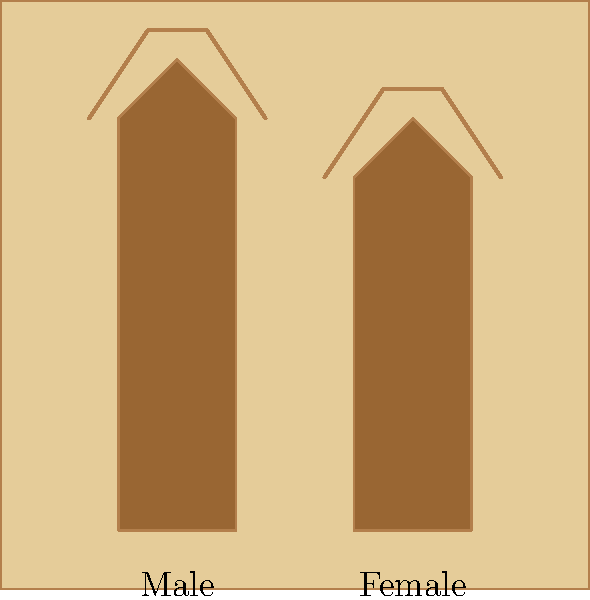Analyze the representation of gender in this simplified ancient Egyptian-style artwork. What key difference in the depiction of the male and female figures challenges traditional assumptions about gender roles in ancient Egyptian society? To answer this question, we need to analyze the image carefully and consider its implications for gender representation in ancient Egyptian art:

1. Overall composition: The image shows two stylized figures, one labeled male and one labeled female, in a typical ancient Egyptian artistic style.

2. Height comparison: Contrary to many ancient artistic traditions, the male and female figures are depicted at almost equal heights. The male figure is only slightly taller than the female figure.

3. Posture and stance: Both figures are shown in a similar, upright posture, suggesting equal status and importance.

4. Crowns: Both figures wear crowns, which in ancient Egyptian art often signify royalty, divinity, or high social status. The presence of crowns on both figures implies equal access to power and authority.

5. Clothing: The simplified representation doesn't show significant differences in clothing between the male and female figures, further emphasizing their equality.

6. Proportions: The body proportions of both figures are similar, without exaggerated sexual characteristics that might emphasize gender differences.

The key difference challenging traditional assumptions is the near-equal height and status representation of the male and female figures. This contrasts with many ancient artistic traditions where male figures are often depicted as significantly larger or in more dominant positions than female figures.

This representation suggests a more egalitarian view of gender roles in ancient Egyptian society, at least in some contexts or periods, challenging the assumption that ancient societies were universally patriarchal or that women were always depicted as subordinate to men in ancient art.
Answer: Near-equal height and status representation of male and female figures 